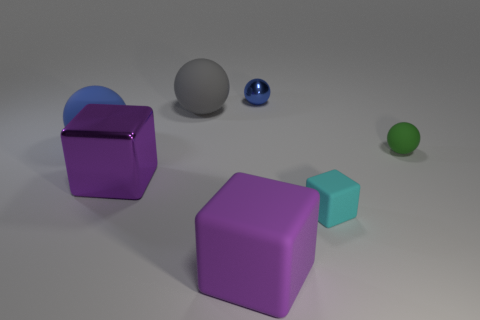How many objects are big blue things or big purple metallic cubes left of the tiny blue object?
Offer a terse response. 2. Is the size of the blue ball that is behind the gray thing the same as the green rubber object?
Offer a terse response. Yes. What number of other things are there of the same size as the gray ball?
Keep it short and to the point. 3. The tiny metallic ball has what color?
Your answer should be compact. Blue. What is the material of the tiny sphere that is behind the small green thing?
Your answer should be compact. Metal. Are there the same number of cyan rubber things that are on the left side of the blue matte ball and tiny green metallic cubes?
Keep it short and to the point. Yes. Do the small cyan thing and the large metallic object have the same shape?
Provide a short and direct response. Yes. Is there anything else of the same color as the big rubber block?
Provide a succinct answer. Yes. The small object that is both left of the tiny green object and in front of the small metallic object has what shape?
Your response must be concise. Cube. Are there an equal number of balls that are to the right of the tiny shiny ball and big blue balls to the right of the gray rubber object?
Provide a short and direct response. No. 